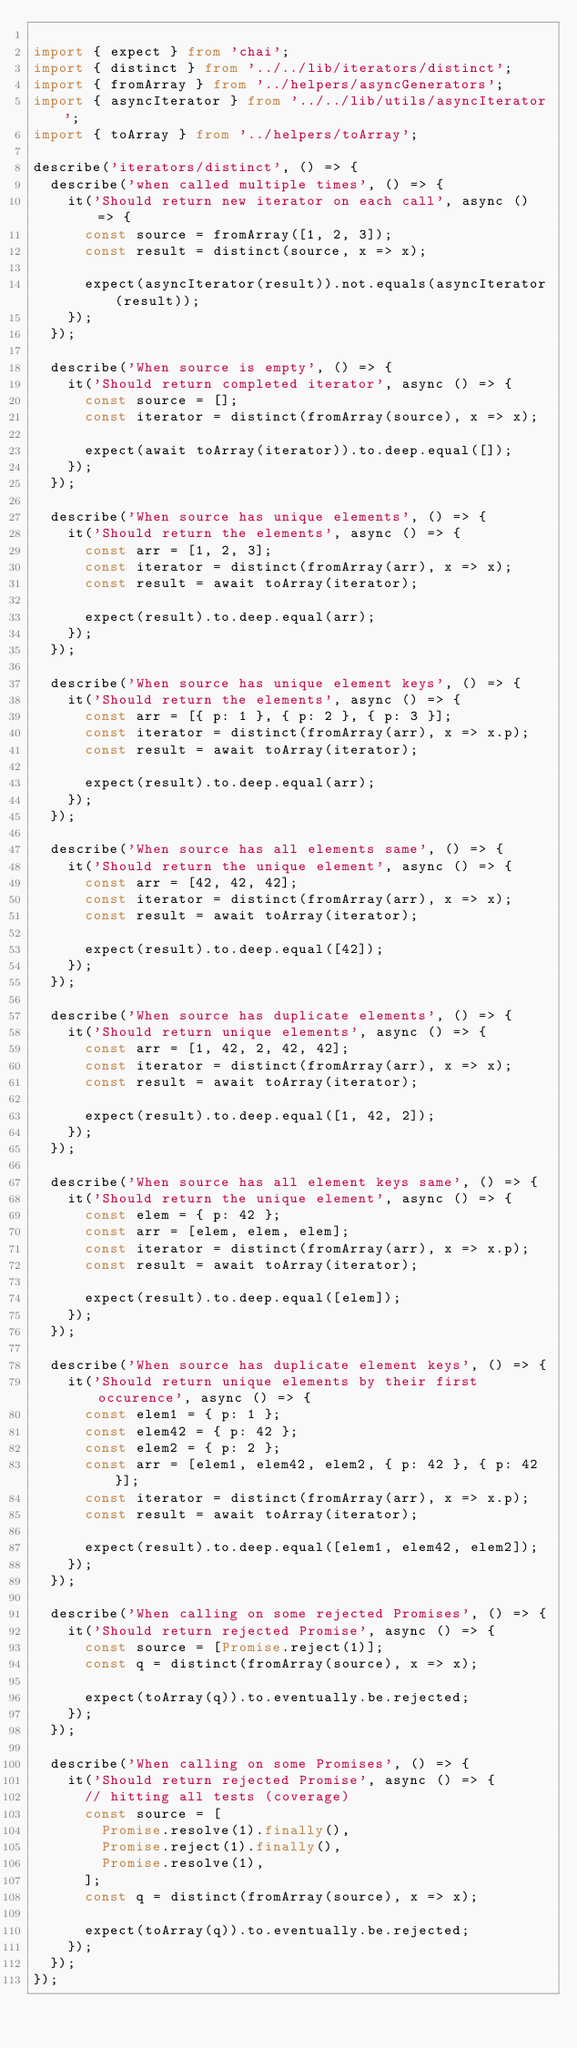Convert code to text. <code><loc_0><loc_0><loc_500><loc_500><_TypeScript_>
import { expect } from 'chai';
import { distinct } from '../../lib/iterators/distinct';
import { fromArray } from '../helpers/asyncGenerators';
import { asyncIterator } from '../../lib/utils/asyncIterator';
import { toArray } from '../helpers/toArray';

describe('iterators/distinct', () => {
  describe('when called multiple times', () => {
    it('Should return new iterator on each call', async () => {
      const source = fromArray([1, 2, 3]);
      const result = distinct(source, x => x);

      expect(asyncIterator(result)).not.equals(asyncIterator(result));
    });
  });

  describe('When source is empty', () => {
    it('Should return completed iterator', async () => {
      const source = [];
      const iterator = distinct(fromArray(source), x => x);

      expect(await toArray(iterator)).to.deep.equal([]);
    });
  });

  describe('When source has unique elements', () => {
    it('Should return the elements', async () => {
      const arr = [1, 2, 3];
      const iterator = distinct(fromArray(arr), x => x);
      const result = await toArray(iterator);

      expect(result).to.deep.equal(arr);
    });
  });

  describe('When source has unique element keys', () => {
    it('Should return the elements', async () => {
      const arr = [{ p: 1 }, { p: 2 }, { p: 3 }];
      const iterator = distinct(fromArray(arr), x => x.p);
      const result = await toArray(iterator);

      expect(result).to.deep.equal(arr);
    });
  });

  describe('When source has all elements same', () => {
    it('Should return the unique element', async () => {
      const arr = [42, 42, 42];
      const iterator = distinct(fromArray(arr), x => x);
      const result = await toArray(iterator);

      expect(result).to.deep.equal([42]);
    });
  });

  describe('When source has duplicate elements', () => {
    it('Should return unique elements', async () => {
      const arr = [1, 42, 2, 42, 42];
      const iterator = distinct(fromArray(arr), x => x);
      const result = await toArray(iterator);

      expect(result).to.deep.equal([1, 42, 2]);
    });
  });

  describe('When source has all element keys same', () => {
    it('Should return the unique element', async () => {
      const elem = { p: 42 };
      const arr = [elem, elem, elem];
      const iterator = distinct(fromArray(arr), x => x.p);
      const result = await toArray(iterator);

      expect(result).to.deep.equal([elem]);
    });
  });

  describe('When source has duplicate element keys', () => {
    it('Should return unique elements by their first occurence', async () => {
      const elem1 = { p: 1 };
      const elem42 = { p: 42 };
      const elem2 = { p: 2 };
      const arr = [elem1, elem42, elem2, { p: 42 }, { p: 42 }];
      const iterator = distinct(fromArray(arr), x => x.p);
      const result = await toArray(iterator);

      expect(result).to.deep.equal([elem1, elem42, elem2]);
    });
  });

  describe('When calling on some rejected Promises', () => {
    it('Should return rejected Promise', async () => {
      const source = [Promise.reject(1)];
      const q = distinct(fromArray(source), x => x);

      expect(toArray(q)).to.eventually.be.rejected;
    });
  });

  describe('When calling on some Promises', () => {
    it('Should return rejected Promise', async () => {
      // hitting all tests (coverage)
      const source = [
        Promise.resolve(1).finally(),
        Promise.reject(1).finally(),
        Promise.resolve(1),
      ];
      const q = distinct(fromArray(source), x => x);

      expect(toArray(q)).to.eventually.be.rejected;
    });
  });
});
</code> 